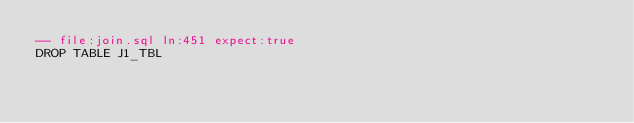<code> <loc_0><loc_0><loc_500><loc_500><_SQL_>-- file:join.sql ln:451 expect:true
DROP TABLE J1_TBL
</code> 